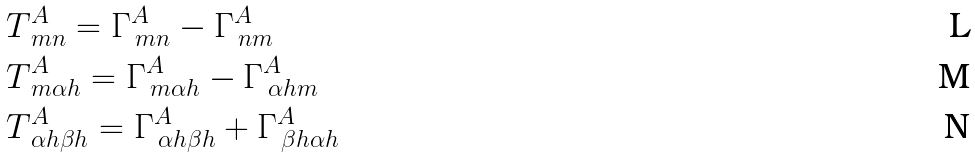Convert formula to latex. <formula><loc_0><loc_0><loc_500><loc_500>& T ^ { A } _ { \, m n } = \Gamma ^ { A } _ { \, m n } - \Gamma ^ { A } _ { \, n m } \\ & T ^ { A } _ { \, m \alpha h } = \Gamma ^ { A } _ { \, m \alpha h } - \Gamma ^ { A } _ { \, \alpha h m } \\ & T ^ { A } _ { \, \alpha h \beta h } = \Gamma ^ { A } _ { \, \alpha h \beta h } + \Gamma ^ { A } _ { \, \beta h \alpha h }</formula> 